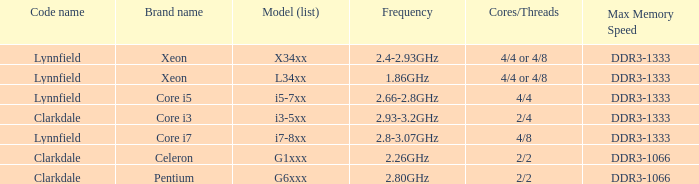What brand is model G6xxx? Pentium. 